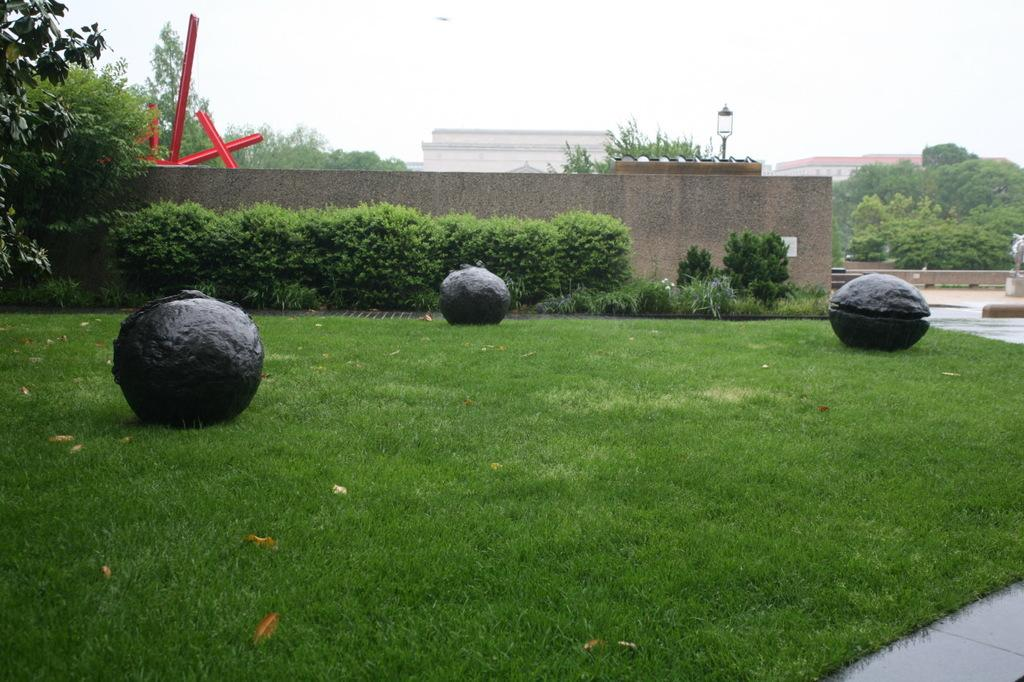How many balls are visible on the ground in the image? There are three balls placed on the ground in the image. What can be seen in the background of the image? There is a group of plants, buildings, poles, and the sky visible in the background. Can you describe the plants in the background? The group of plants in the background is not described in detail, but they are visible. What type of nut is being used to play the game with the balls in the image? There is no nut present in the image, and the balls are not being used for any game. 